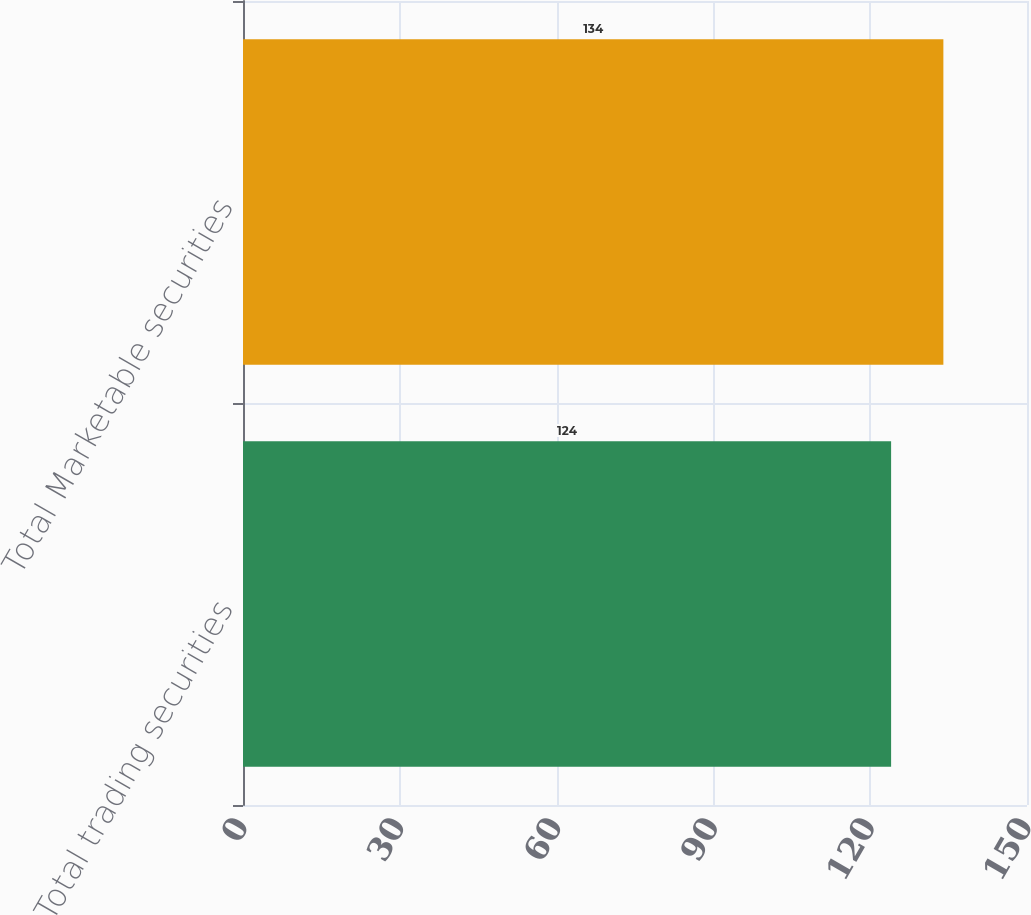Convert chart to OTSL. <chart><loc_0><loc_0><loc_500><loc_500><bar_chart><fcel>Total trading securities<fcel>Total Marketable securities<nl><fcel>124<fcel>134<nl></chart> 